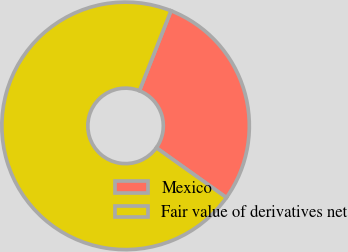Convert chart. <chart><loc_0><loc_0><loc_500><loc_500><pie_chart><fcel>Mexico<fcel>Fair value of derivatives net<nl><fcel>28.86%<fcel>71.14%<nl></chart> 